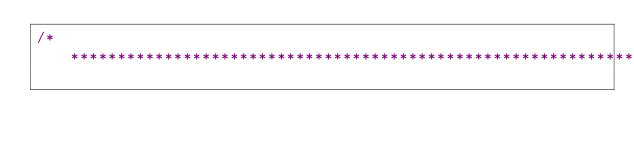<code> <loc_0><loc_0><loc_500><loc_500><_Ceylon_>/********************************************************************************</code> 